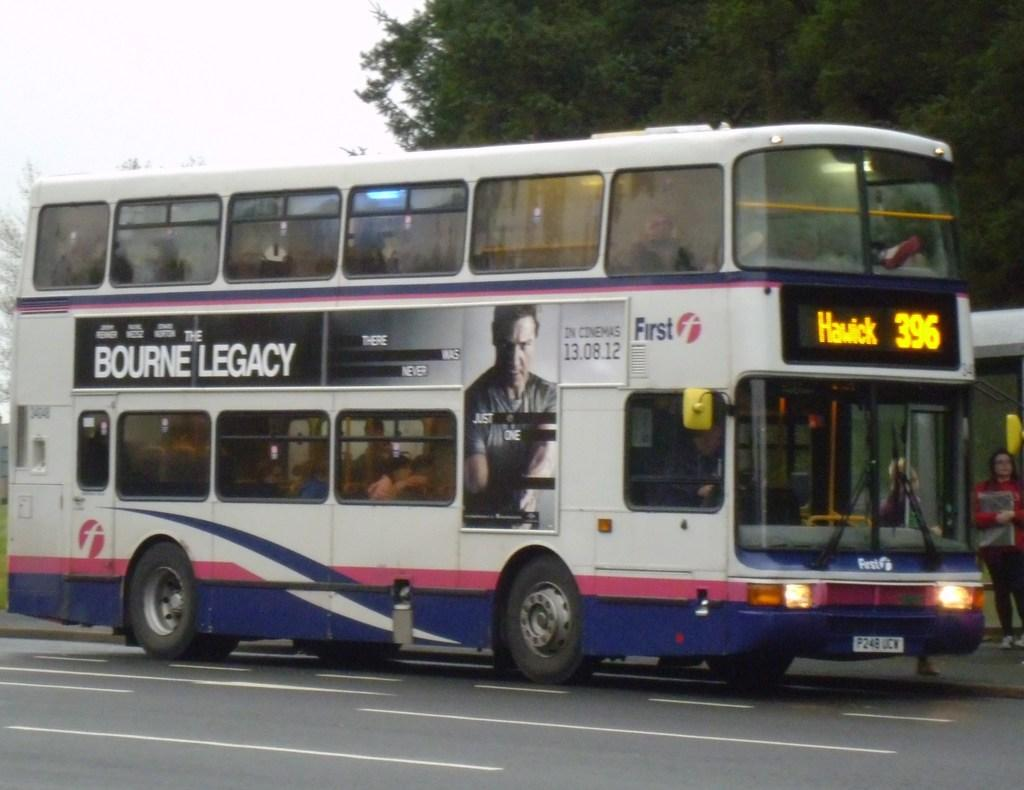Provide a one-sentence caption for the provided image. Bus number 396 has an ad for The Bourne Legacy. 